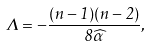Convert formula to latex. <formula><loc_0><loc_0><loc_500><loc_500>\Lambda = - \frac { ( n - 1 ) ( n - 2 ) } { 8 \widehat { \alpha } } ,</formula> 